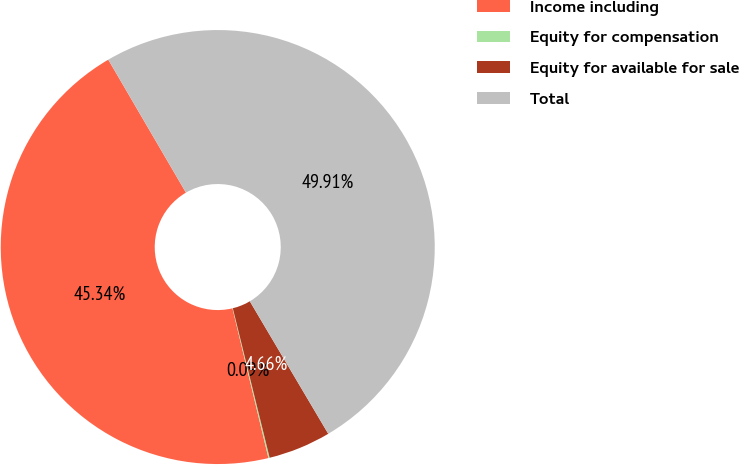Convert chart. <chart><loc_0><loc_0><loc_500><loc_500><pie_chart><fcel>Income including<fcel>Equity for compensation<fcel>Equity for available for sale<fcel>Total<nl><fcel>45.34%<fcel>0.09%<fcel>4.66%<fcel>49.91%<nl></chart> 